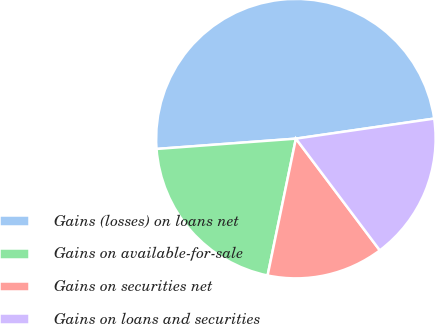Convert chart. <chart><loc_0><loc_0><loc_500><loc_500><pie_chart><fcel>Gains (losses) on loans net<fcel>Gains on available-for-sale<fcel>Gains on securities net<fcel>Gains on loans and securities<nl><fcel>48.89%<fcel>20.58%<fcel>13.5%<fcel>17.04%<nl></chart> 